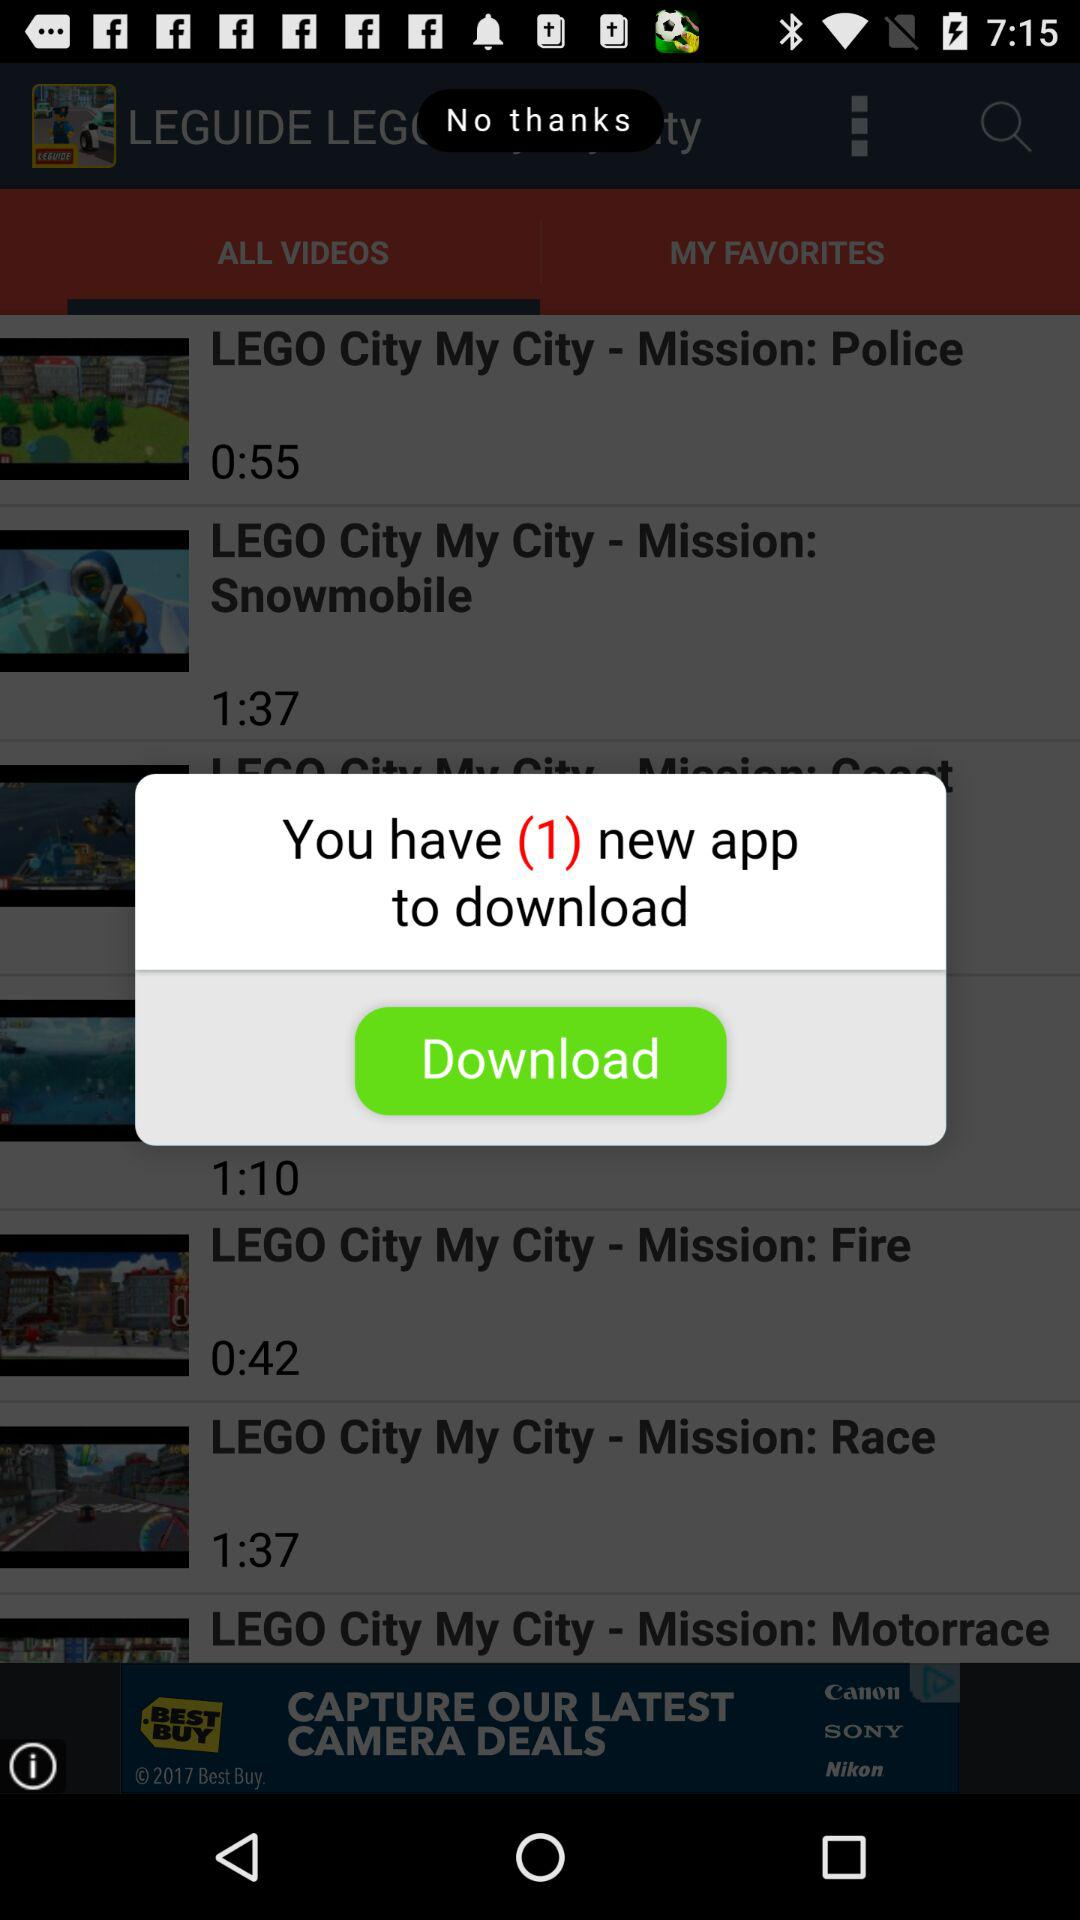How many download options are available?
Answer the question using a single word or phrase. 1 